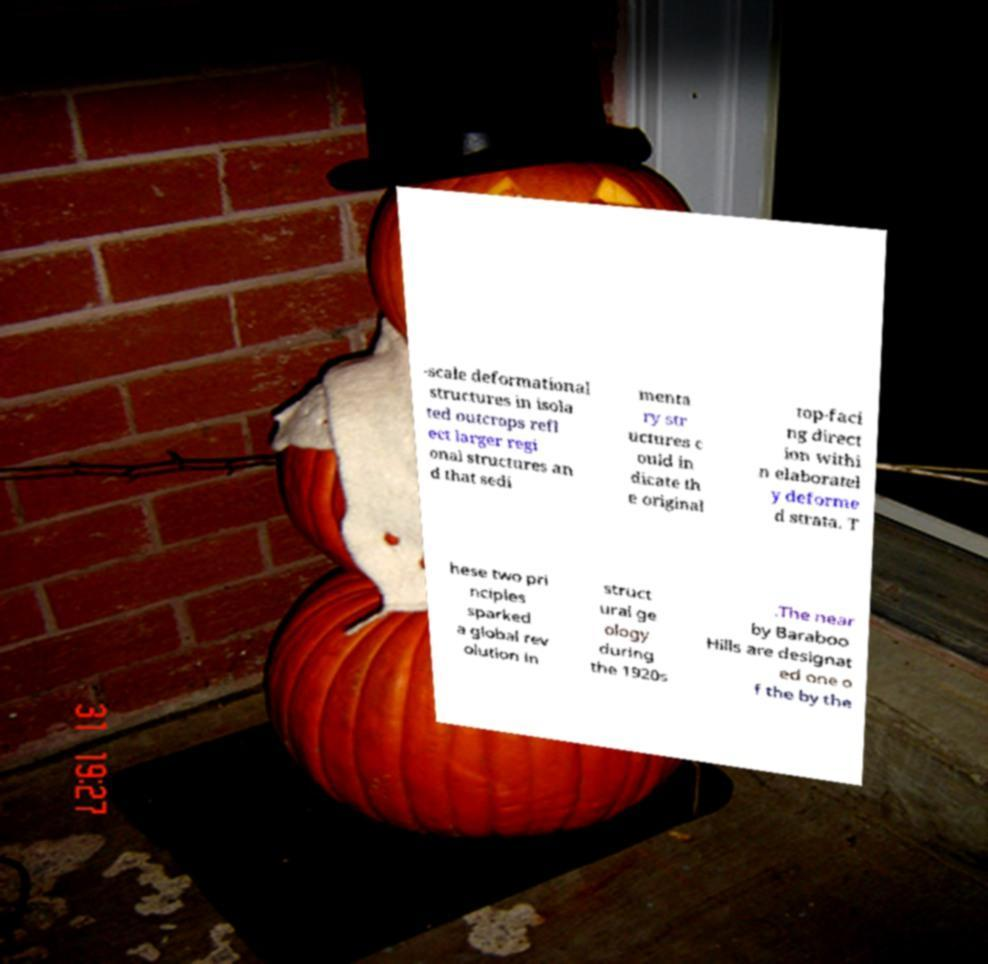Please identify and transcribe the text found in this image. -scale deformational structures in isola ted outcrops refl ect larger regi onal structures an d that sedi menta ry str uctures c ould in dicate th e original top-faci ng direct ion withi n elaboratel y deforme d strata. T hese two pri nciples sparked a global rev olution in struct ural ge ology during the 1920s .The near by Baraboo Hills are designat ed one o f the by the 